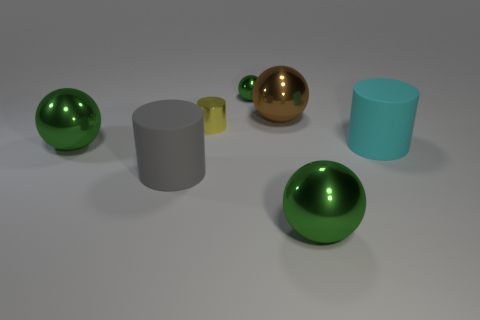What is the size of the other matte object that is the same shape as the cyan matte thing?
Offer a terse response. Large. What size is the yellow shiny thing?
Your answer should be very brief. Small. Is the number of big metal things in front of the small yellow object greater than the number of yellow balls?
Your response must be concise. Yes. There is a ball that is left of the tiny yellow cylinder; is it the same color as the tiny metal thing behind the tiny yellow shiny cylinder?
Your answer should be very brief. Yes. There is a green sphere that is behind the matte thing that is to the right of the green ball right of the brown thing; what is it made of?
Give a very brief answer. Metal. Are there more big shiny objects than tiny purple cubes?
Your response must be concise. Yes. Are there any other things of the same color as the small metallic cylinder?
Keep it short and to the point. No. There is a brown object that is made of the same material as the yellow object; what is its size?
Make the answer very short. Large. What is the large cyan object made of?
Your answer should be compact. Rubber. What number of brown metal spheres are the same size as the gray cylinder?
Offer a very short reply. 1. 